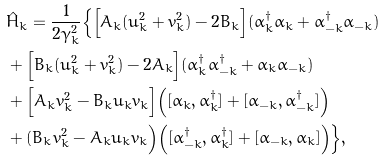Convert formula to latex. <formula><loc_0><loc_0><loc_500><loc_500>& \hat { H } _ { k } = \frac { 1 } { 2 \gamma _ { k } ^ { 2 } } \Big \{ \Big [ A _ { k } ( u _ { k } ^ { 2 } + v _ { k } ^ { 2 } ) - 2 B _ { k } \Big ] ( \alpha _ { k } ^ { \dagger } \alpha _ { k } + \alpha _ { - k } ^ { \dagger } \alpha _ { - k } ) \\ & + \Big [ B _ { k } ( u _ { k } ^ { 2 } + v _ { k } ^ { 2 } ) - 2 A _ { k } \Big ] ( \alpha _ { k } ^ { \dagger } \alpha _ { - k } ^ { \dagger } + \alpha _ { k } \alpha _ { - k } ) \\ & + \Big [ A _ { k } v _ { k } ^ { 2 } - B _ { k } u _ { k } v _ { k } \Big ] \Big ( [ \alpha _ { k } , \alpha _ { k } ^ { \dagger } ] + [ \alpha _ { - k } , \alpha _ { - k } ^ { \dagger } ] \Big ) \\ & + ( B _ { k } v _ { k } ^ { 2 } - A _ { k } u _ { k } v _ { k } \Big ) \Big ( [ \alpha _ { - k } ^ { \dagger } , \alpha _ { k } ^ { \dagger } ] + [ \alpha _ { - k } , \alpha _ { k } ] \Big ) \Big \} ,</formula> 